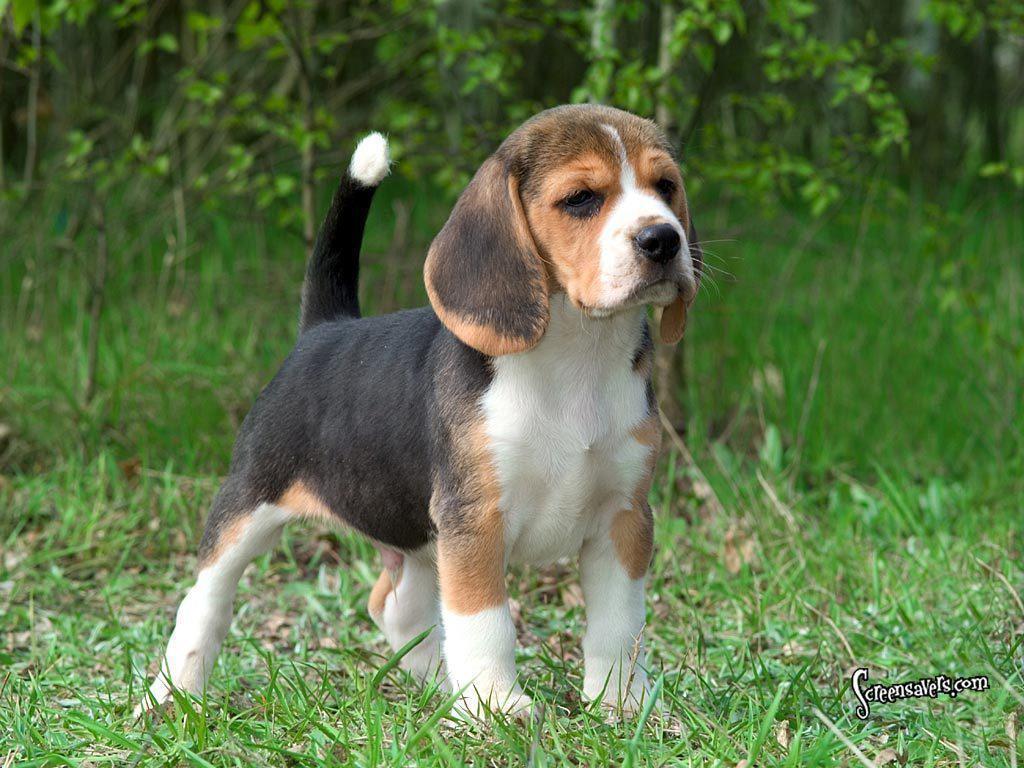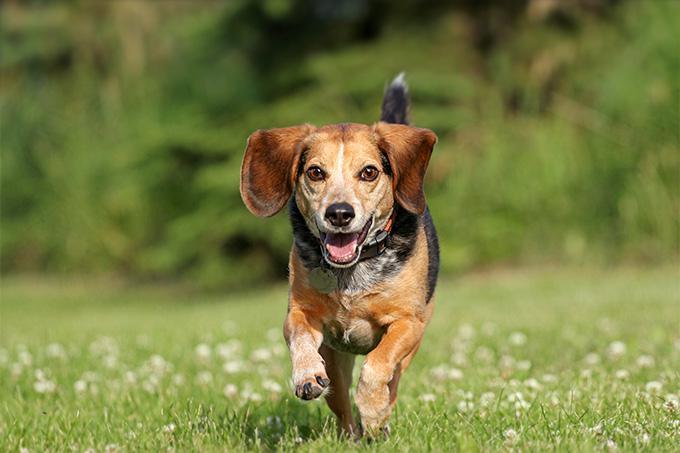The first image is the image on the left, the second image is the image on the right. Analyze the images presented: Is the assertion "One of the puppies is running through the grass." valid? Answer yes or no. Yes. 